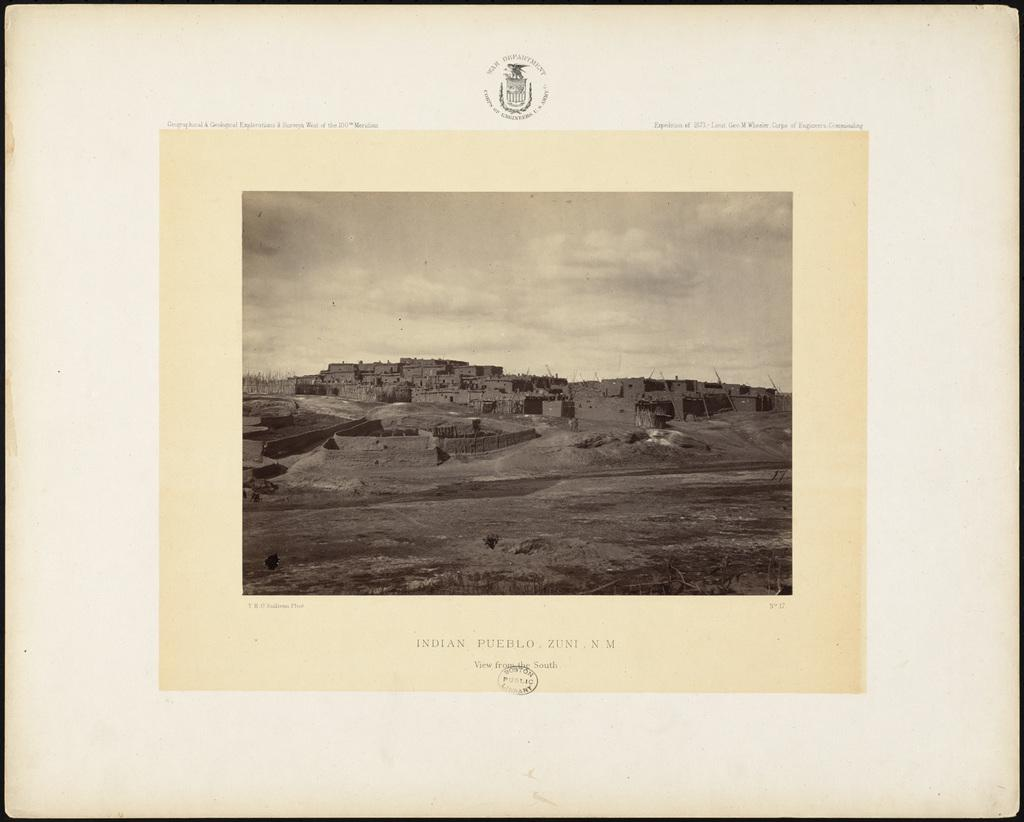<image>
Share a concise interpretation of the image provided. a photo of a building with the word pueblo at the bottom 